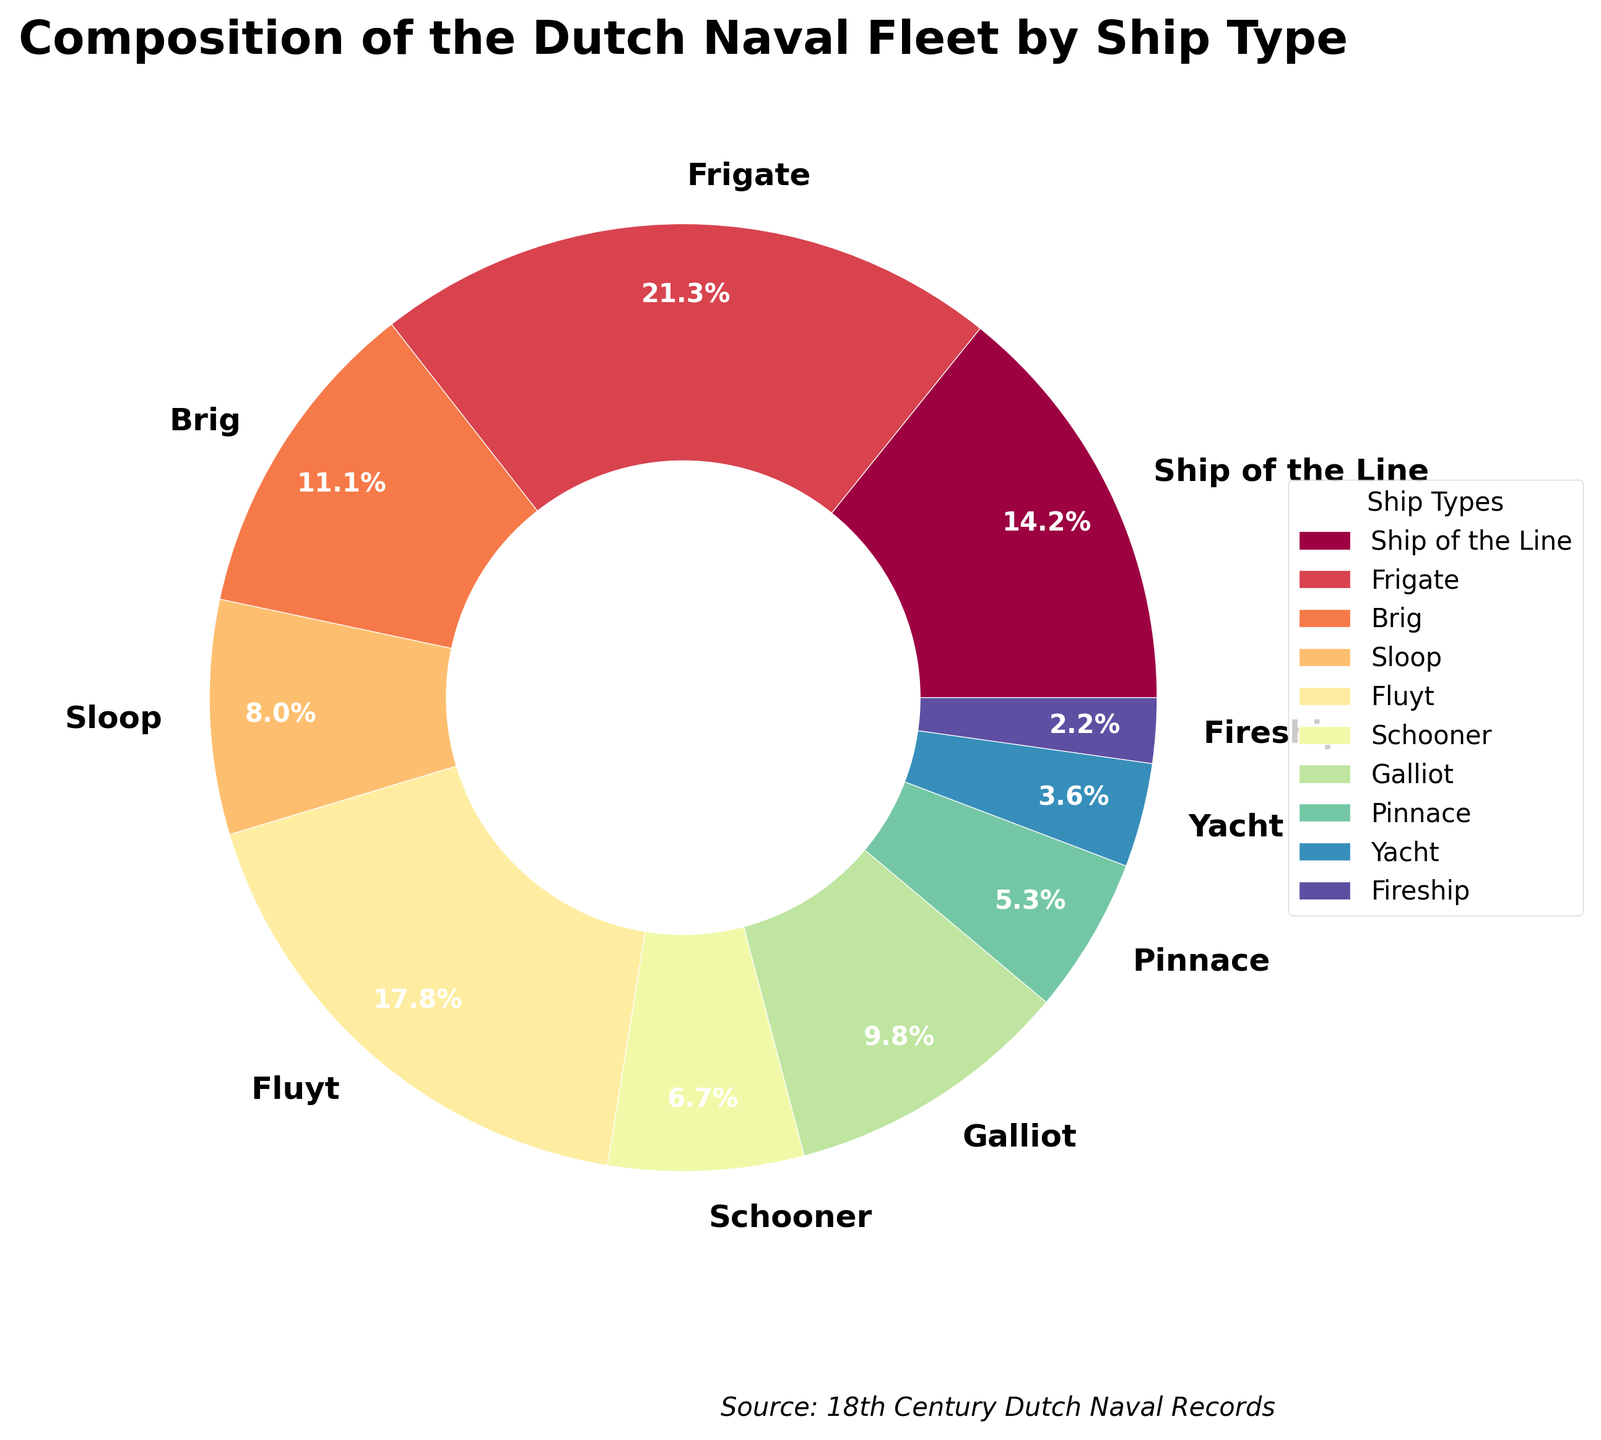What percentage of the fleet is composed of Frigates? The pie chart's segment labeled 'Frigate' shows a percentage of 48 ships out of the total. The chart also displays the percentage for each segment.
Answer: 23.2% How many more Frigates are there than Ships of the Line? There are 48 Frigates and 32 Ships of the Line. Subtract the number of Ships of the Line from the number of Frigates: 48 - 32 = 16.
Answer: 16 Are there more Fluyts or Galliots in the fleet? The pie chart shows that there are 40 Fluyts and 22 Galliots. Comparing these two numbers, there are more Fluyts.
Answer: Fluyts Which ship type has the smallest representation in the fleet? The segment labeled 'Fireship' has the smallest slice in the pie chart, indicating they have the least number of ships.
Answer: Fireship What is the combined percentage of Sloops and Brigs? The pie chart shows that there are 18 Sloops and 25 Brigs. To find the combined percentage, sum their percentages from the chart: (8.7% + 12.1%).
Answer: 20.8% How does the number of Galliots compare to the number of Pinnaces and Yachts combined? There are 22 Galliots, 12 Pinnaces, and 8 Yachts. Summing the number of Pinnaces and Yachts: 12 + 8 = 20. Since 22 Galliots > 20 Pinnaces and Yachts combined, the Galliots are greater in number.
Answer: Greater Which ship type, Schooner or Fireship, takes up more percentage of the fleet? The pie chart's segments labeled 'Schooner' and 'Fireship' can be compared directly. The Schooner's segment is larger, indicating it takes up more percentage of the fleet.
Answer: Schooner What percentage of the fleet do the largest and smallest ship types together account for? The largest proportion is for Frigates (48 ships - 23.2%), and the smallest is Fireships (5 ships). Adding these percentages: 23.2% + Fireship percentage (based on smallest slice and calculated as roughly 2.4%).
Answer: 25.6% What is the difference in percentage between the Yacht and the Schooner? The pie chart shows that Yachts make up a smaller percentage compared to Schooners. By manually checking the chart, approximate the Yacht to around 2% and Schooner to 7.3% and find the difference: 7.3% - 2%.
Answer: 5.3% Which ship types make up at least 10% of the fleet individually? Reviewing the segments, we recognize Frigates and Fluyts each making up at least 10% of the fleet. Frigates are noted at 23.2%, and Fluyts approximately calculated at around 19.4%.
Answer: Frigates, Fluyts 